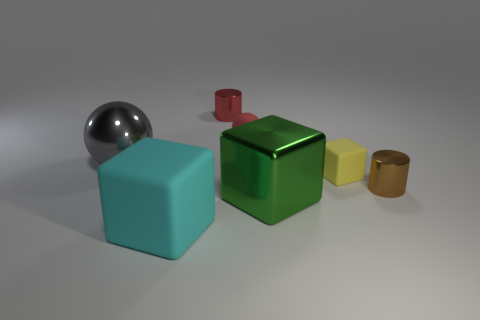There is a large green metallic object; are there any tiny rubber balls to the left of it?
Provide a succinct answer. Yes. There is a brown thing that is the same size as the yellow rubber object; what shape is it?
Your answer should be very brief. Cylinder. Do the red sphere and the tiny block have the same material?
Your answer should be very brief. Yes. What number of rubber things are tiny objects or cyan things?
Ensure brevity in your answer.  3. There is a small thing that is the same color as the tiny sphere; what is its shape?
Your answer should be compact. Cylinder. Do the cylinder on the left side of the green block and the tiny matte ball have the same color?
Offer a very short reply. Yes. What is the shape of the big metallic object that is right of the metallic cylinder behind the gray metallic ball?
Ensure brevity in your answer.  Cube. What number of objects are either big things that are in front of the green metallic object or small red cylinders that are to the right of the large gray thing?
Provide a short and direct response. 2. What is the shape of the gray thing that is made of the same material as the red cylinder?
Offer a very short reply. Sphere. Are there any other things that have the same color as the small rubber ball?
Give a very brief answer. Yes. 